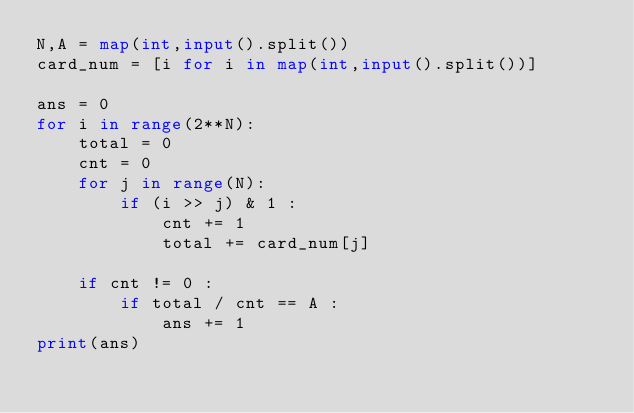Convert code to text. <code><loc_0><loc_0><loc_500><loc_500><_Python_>N,A = map(int,input().split())
card_num = [i for i in map(int,input().split())]

ans = 0 
for i in range(2**N): 
    total = 0
    cnt = 0
    for j in range(N):
        if (i >> j) & 1 :
            cnt += 1
            total += card_num[j]
    
    if cnt != 0 :
        if total / cnt == A :
            ans += 1
print(ans)</code> 